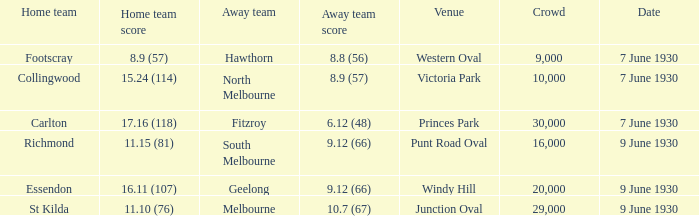What is the average crowd size when North Melbourne is the away team? 10000.0. 